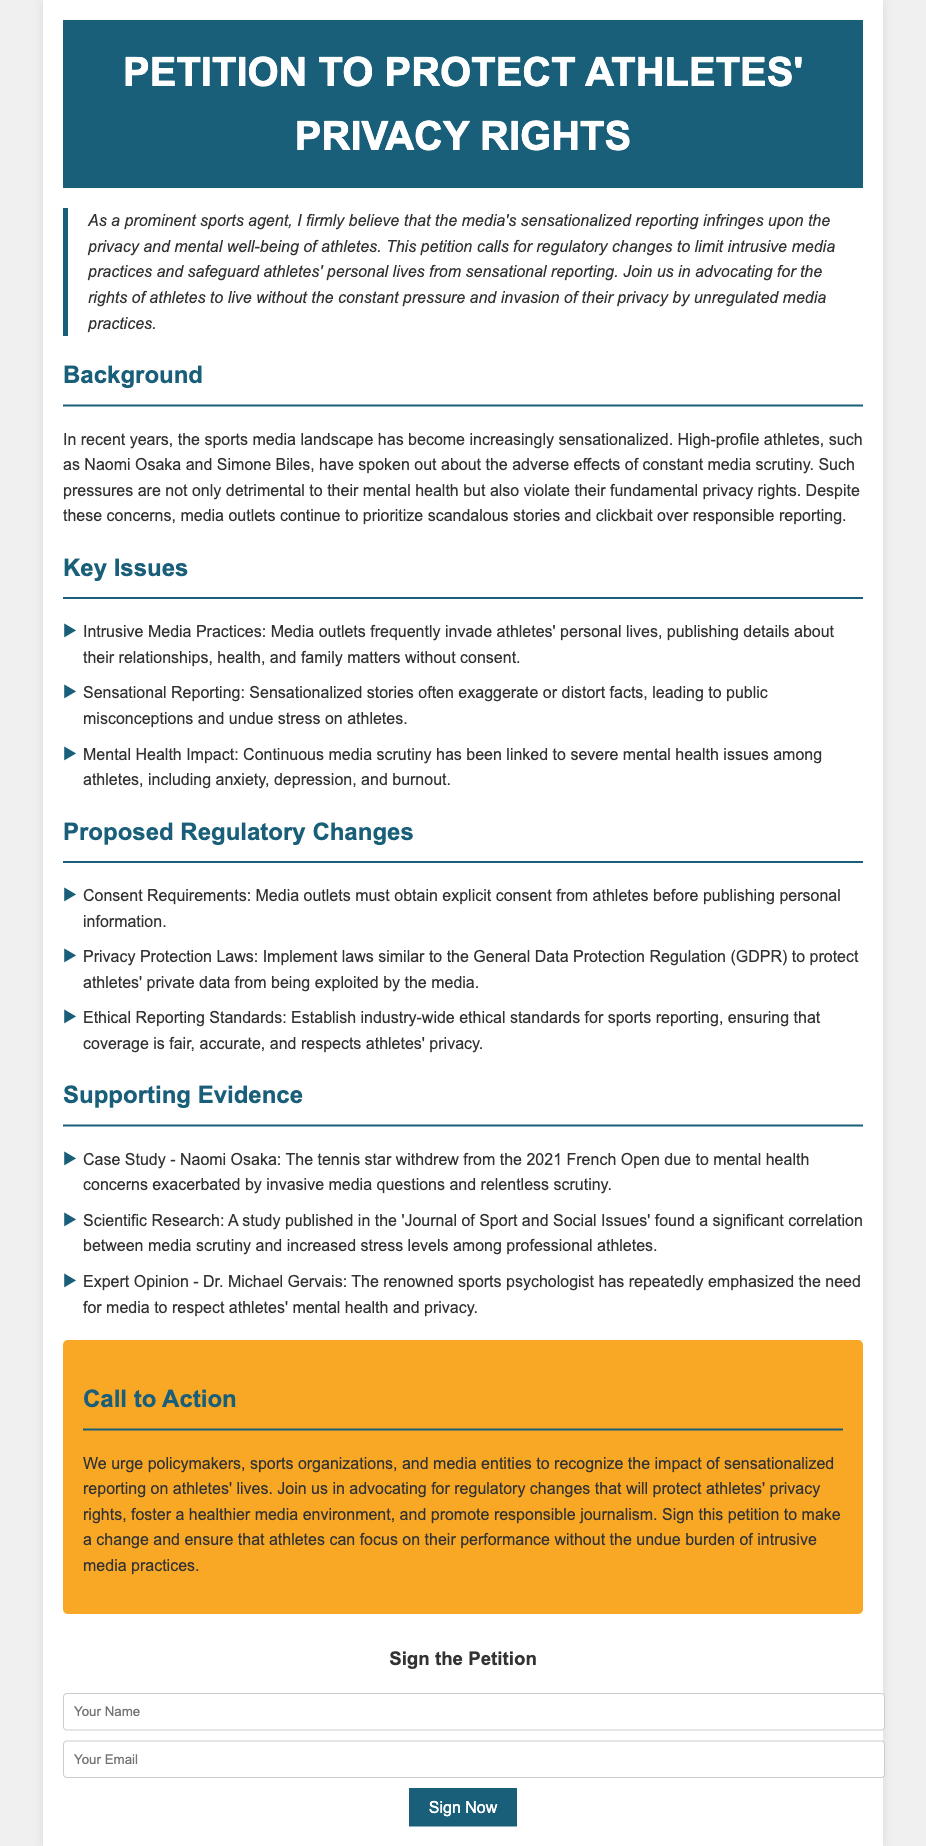What is the title of the petition? The title of the petition is explicitly stated in the header of the document.
Answer: Petition to Protect Athletes' Privacy Rights Who is mentioned as a case study in the supporting evidence? The document lists Naomi Osaka as an example in the supporting evidence section.
Answer: Naomi Osaka What type of laws are proposed to protect athletes' private data? The proposed regulatory changes mention implementing laws similar to the GDPR specifically for privacy protection.
Answer: Privacy Protection Laws How many key issues are highlighted in the document? The key issues section lists three specific issues related to media practices and athletes' privacy.
Answer: Three What is the background issue discussed regarding the media? The background section discusses the increasing sensationalized nature of the sports media landscape.
Answer: Sensationalized Reporting Who is the expert mentioned in the supporting evidence? The supporting evidence references Dr. Michael Gervais as an expert opinion contributor.
Answer: Dr. Michael Gervais What is the main focus of the call to action? The call to action urges various entities to recognize the impact of sensationalized reporting on athletes.
Answer: Protect athletes' privacy rights What section outlines proposed regulatory changes? The section that outlines proposed regulations is clearly labeled in the document for clarity.
Answer: Proposed Regulatory Changes 